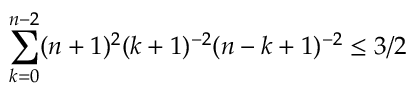<formula> <loc_0><loc_0><loc_500><loc_500>\sum _ { k = 0 } ^ { n - 2 } ( n + 1 ) ^ { 2 } ( k + 1 ) ^ { - 2 } ( n - k + 1 ) ^ { - 2 } \leq 3 / 2</formula> 